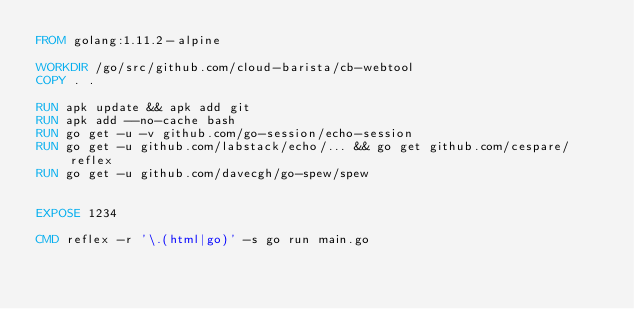Convert code to text. <code><loc_0><loc_0><loc_500><loc_500><_Dockerfile_>FROM golang:1.11.2-alpine

WORKDIR /go/src/github.com/cloud-barista/cb-webtool 
COPY . .

RUN apk update && apk add git
RUN apk add --no-cache bash
RUN go get -u -v github.com/go-session/echo-session
RUN go get -u github.com/labstack/echo/... && go get github.com/cespare/reflex
RUN go get -u github.com/davecgh/go-spew/spew


EXPOSE 1234

CMD reflex -r '\.(html|go)' -s go run main.go
</code> 